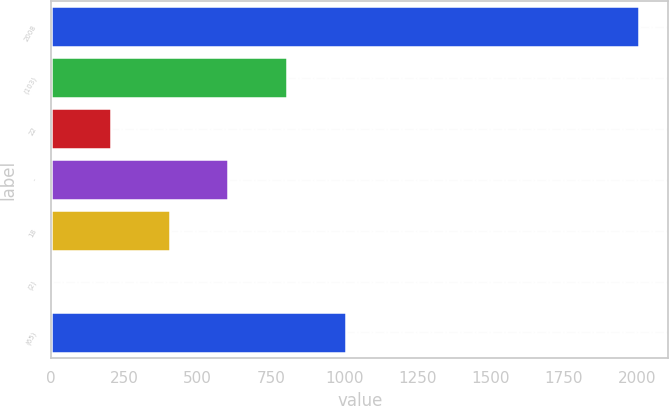<chart> <loc_0><loc_0><loc_500><loc_500><bar_chart><fcel>2008<fcel>(103)<fcel>22<fcel>-<fcel>18<fcel>(2)<fcel>(65)<nl><fcel>2006<fcel>804.8<fcel>204.2<fcel>604.6<fcel>404.4<fcel>4<fcel>1005<nl></chart> 